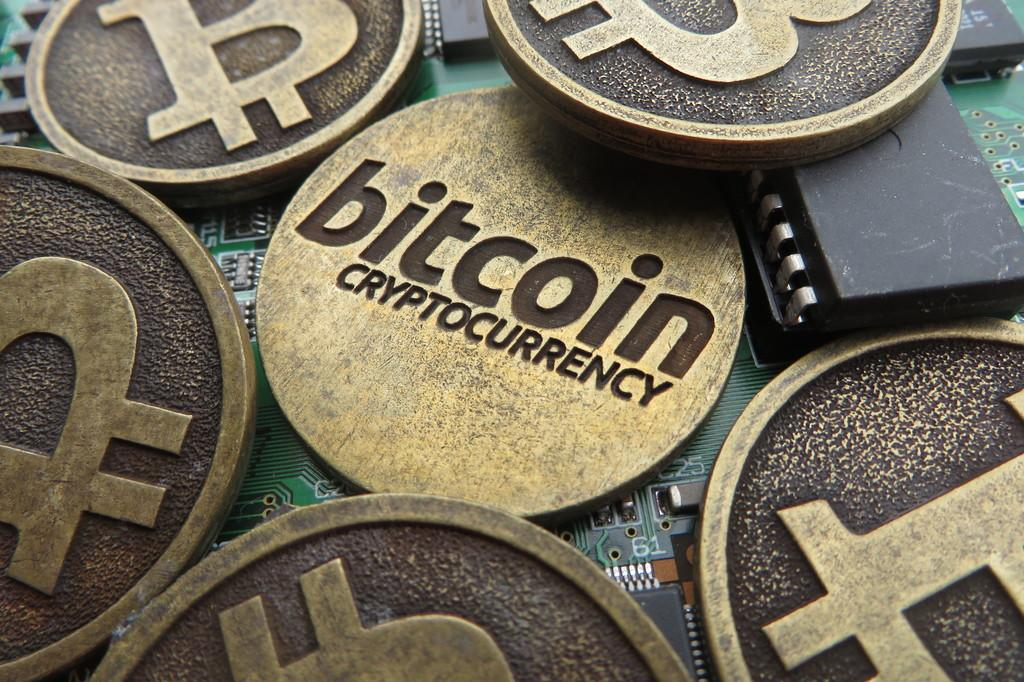<image>
Summarize the visual content of the image. Units of bitcoin cryptocurrency are scattered across a computer circuit board. 